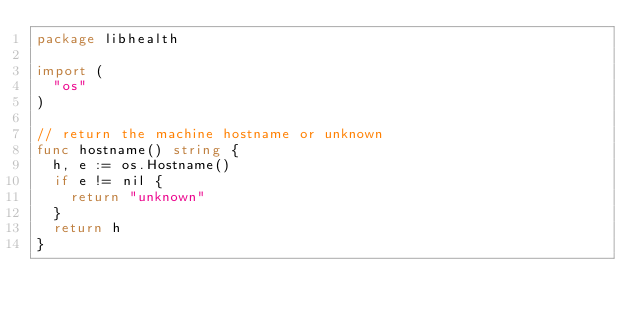<code> <loc_0><loc_0><loc_500><loc_500><_Go_>package libhealth

import (
	"os"
)

// return the machine hostname or unknown
func hostname() string {
	h, e := os.Hostname()
	if e != nil {
		return "unknown"
	}
	return h
}
</code> 